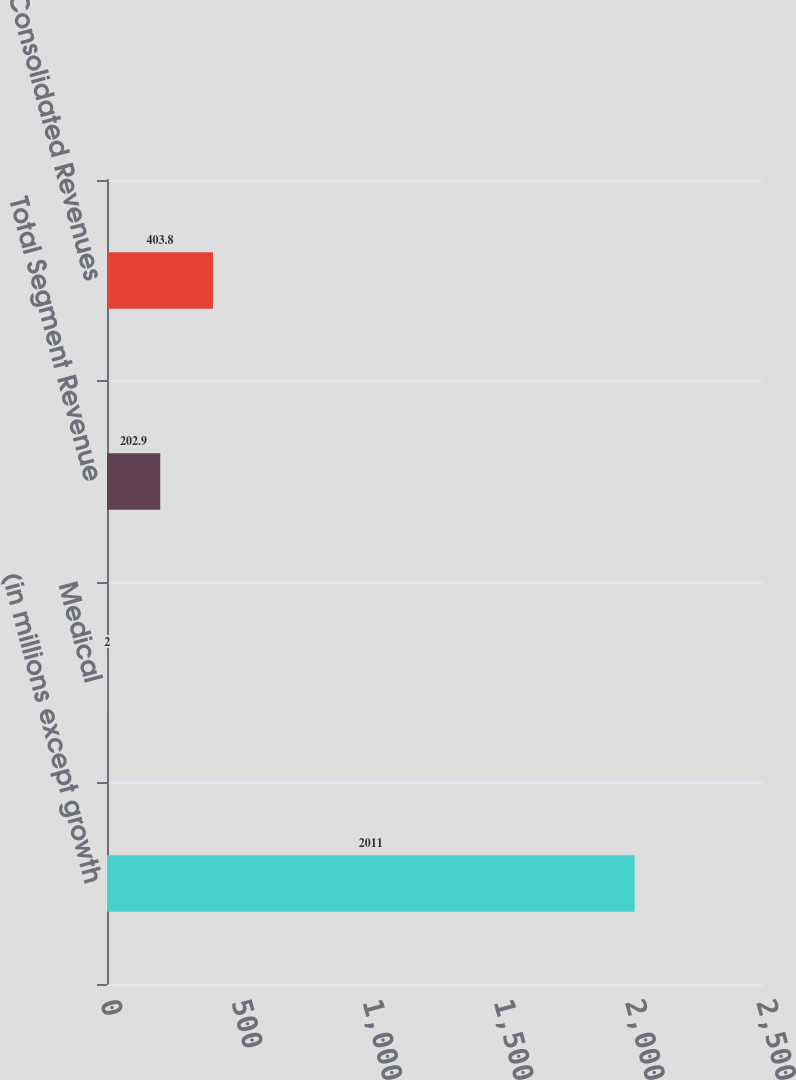Convert chart. <chart><loc_0><loc_0><loc_500><loc_500><bar_chart><fcel>(in millions except growth<fcel>Medical<fcel>Total Segment Revenue<fcel>Consolidated Revenues<nl><fcel>2011<fcel>2<fcel>202.9<fcel>403.8<nl></chart> 